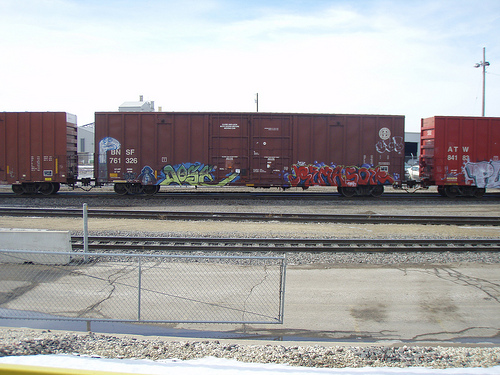<image>
Is there a wheels under the box? Yes. The wheels is positioned underneath the box, with the box above it in the vertical space. Is the train behind the fence? Yes. From this viewpoint, the train is positioned behind the fence, with the fence partially or fully occluding the train. 